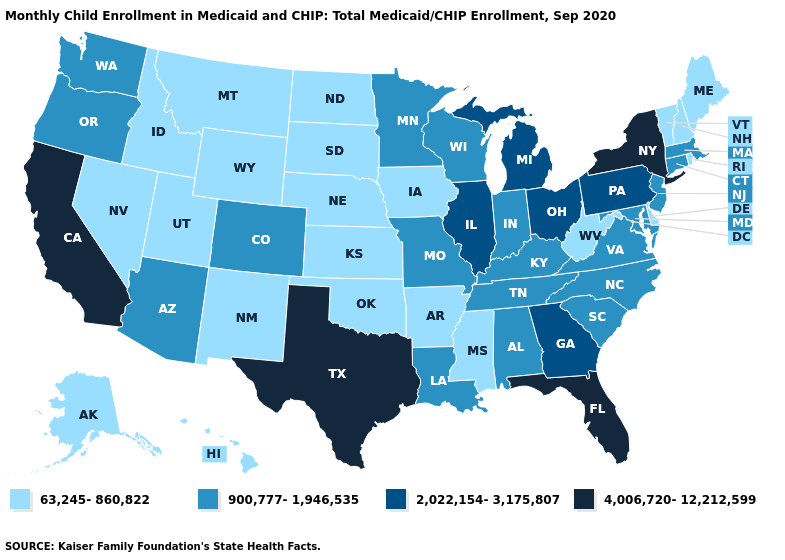What is the value of West Virginia?
Answer briefly. 63,245-860,822. Which states have the highest value in the USA?
Answer briefly. California, Florida, New York, Texas. What is the value of Nevada?
Keep it brief. 63,245-860,822. What is the value of New Mexico?
Keep it brief. 63,245-860,822. What is the value of Nebraska?
Write a very short answer. 63,245-860,822. Name the states that have a value in the range 900,777-1,946,535?
Give a very brief answer. Alabama, Arizona, Colorado, Connecticut, Indiana, Kentucky, Louisiana, Maryland, Massachusetts, Minnesota, Missouri, New Jersey, North Carolina, Oregon, South Carolina, Tennessee, Virginia, Washington, Wisconsin. Does Texas have the highest value in the USA?
Give a very brief answer. Yes. Among the states that border Idaho , which have the highest value?
Quick response, please. Oregon, Washington. Which states have the lowest value in the Northeast?
Keep it brief. Maine, New Hampshire, Rhode Island, Vermont. What is the lowest value in the South?
Keep it brief. 63,245-860,822. Does Missouri have the lowest value in the USA?
Answer briefly. No. How many symbols are there in the legend?
Be succinct. 4. Name the states that have a value in the range 900,777-1,946,535?
Short answer required. Alabama, Arizona, Colorado, Connecticut, Indiana, Kentucky, Louisiana, Maryland, Massachusetts, Minnesota, Missouri, New Jersey, North Carolina, Oregon, South Carolina, Tennessee, Virginia, Washington, Wisconsin. What is the lowest value in states that border Missouri?
Be succinct. 63,245-860,822. Name the states that have a value in the range 63,245-860,822?
Concise answer only. Alaska, Arkansas, Delaware, Hawaii, Idaho, Iowa, Kansas, Maine, Mississippi, Montana, Nebraska, Nevada, New Hampshire, New Mexico, North Dakota, Oklahoma, Rhode Island, South Dakota, Utah, Vermont, West Virginia, Wyoming. 